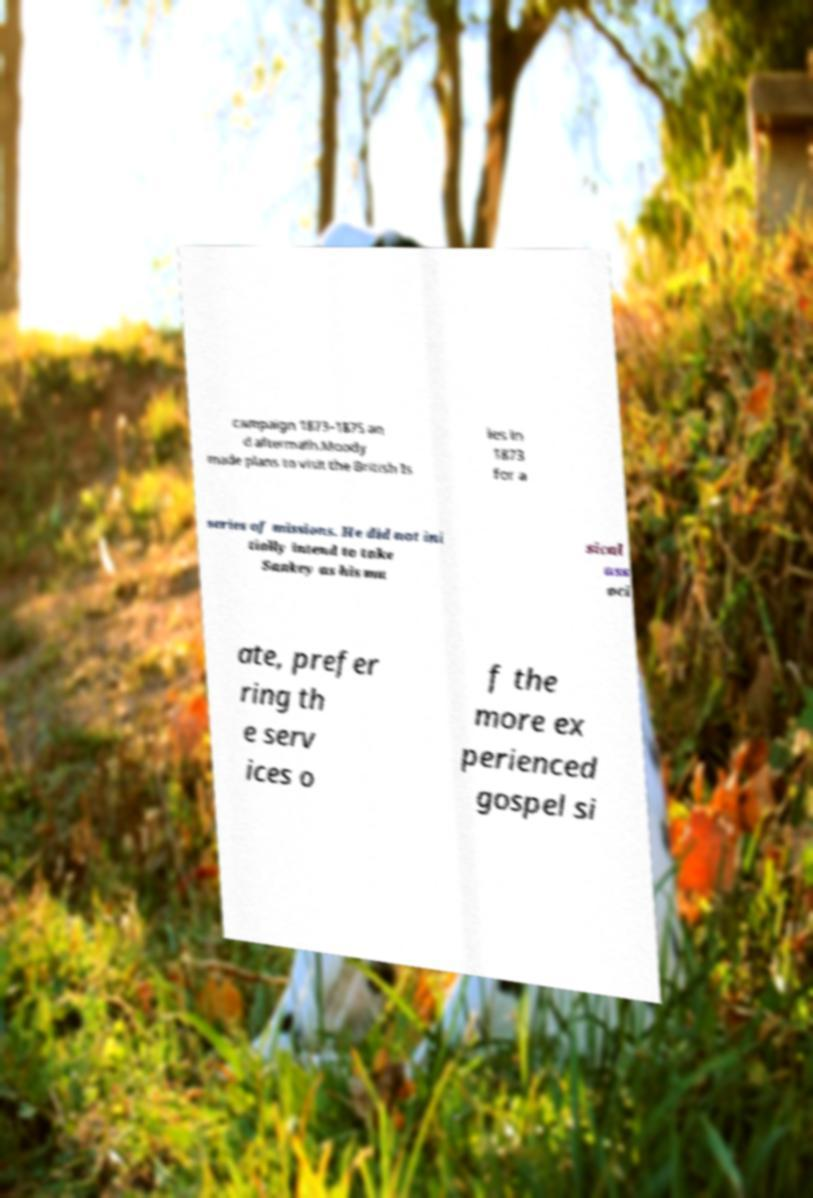Could you extract and type out the text from this image? campaign 1873–1875 an d aftermath.Moody made plans to visit the British Is les in 1873 for a series of missions. He did not ini tially intend to take Sankey as his mu sical ass oci ate, prefer ring th e serv ices o f the more ex perienced gospel si 